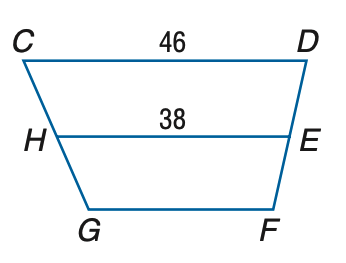Question: Refer to trapezoid C D F G with median H E. Let Y Z be the median of H E F G. Find Y Z.
Choices:
A. 34
B. 38
C. 42
D. 46
Answer with the letter. Answer: A Question: Refer to trapezoid C D F G with median H E. Let W X be the median of C D E H. Find W X.
Choices:
A. 34
B. 38
C. 42
D. 46
Answer with the letter. Answer: C Question: Refer to trapezoid C D F G with median H E. Find G F.
Choices:
A. 30
B. 32
C. 38
D. 46
Answer with the letter. Answer: A 